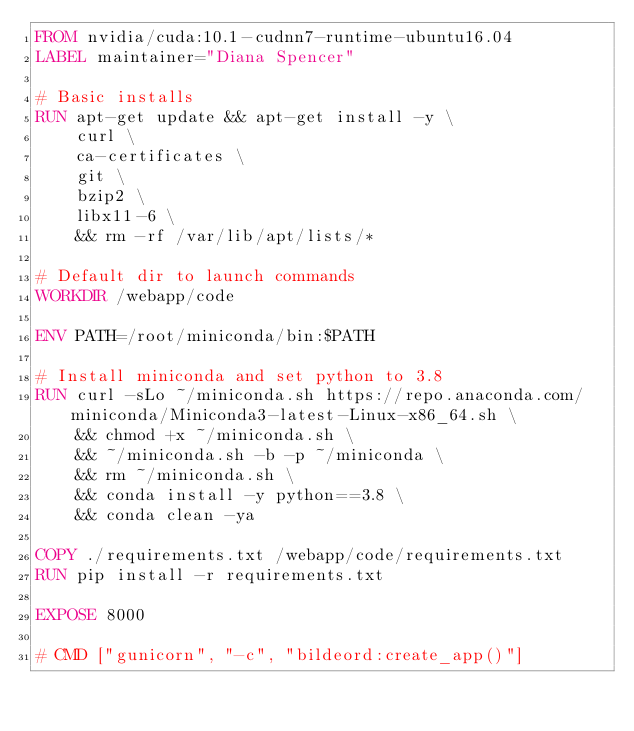Convert code to text. <code><loc_0><loc_0><loc_500><loc_500><_Dockerfile_>FROM nvidia/cuda:10.1-cudnn7-runtime-ubuntu16.04
LABEL maintainer="Diana Spencer"

# Basic installs
RUN apt-get update && apt-get install -y \
    curl \
    ca-certificates \
    git \
    bzip2 \
    libx11-6 \
    && rm -rf /var/lib/apt/lists/*

# Default dir to launch commands
WORKDIR /webapp/code

ENV PATH=/root/miniconda/bin:$PATH

# Install miniconda and set python to 3.8
RUN curl -sLo ~/miniconda.sh https://repo.anaconda.com/miniconda/Miniconda3-latest-Linux-x86_64.sh \
    && chmod +x ~/miniconda.sh \
    && ~/miniconda.sh -b -p ~/miniconda \
    && rm ~/miniconda.sh \
    && conda install -y python==3.8 \
    && conda clean -ya

COPY ./requirements.txt /webapp/code/requirements.txt
RUN pip install -r requirements.txt

EXPOSE 8000

# CMD ["gunicorn", "-c", "bildeord:create_app()"]</code> 